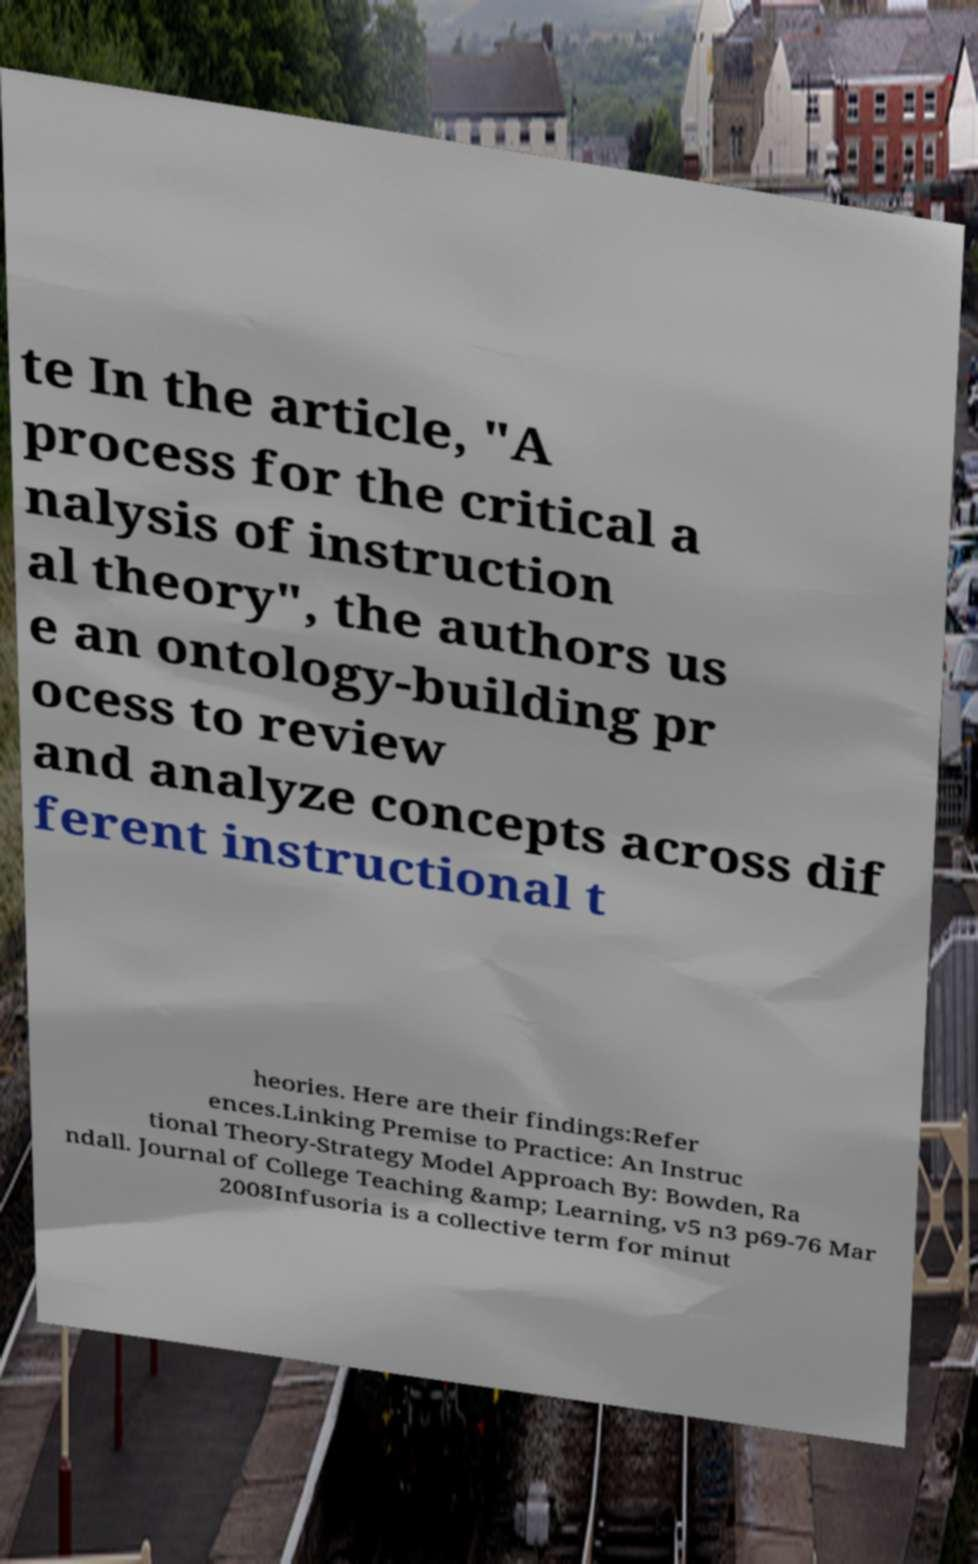I need the written content from this picture converted into text. Can you do that? te In the article, "A process for the critical a nalysis of instruction al theory", the authors us e an ontology-building pr ocess to review and analyze concepts across dif ferent instructional t heories. Here are their findings:Refer ences.Linking Premise to Practice: An Instruc tional Theory-Strategy Model Approach By: Bowden, Ra ndall. Journal of College Teaching &amp; Learning, v5 n3 p69-76 Mar 2008Infusoria is a collective term for minut 